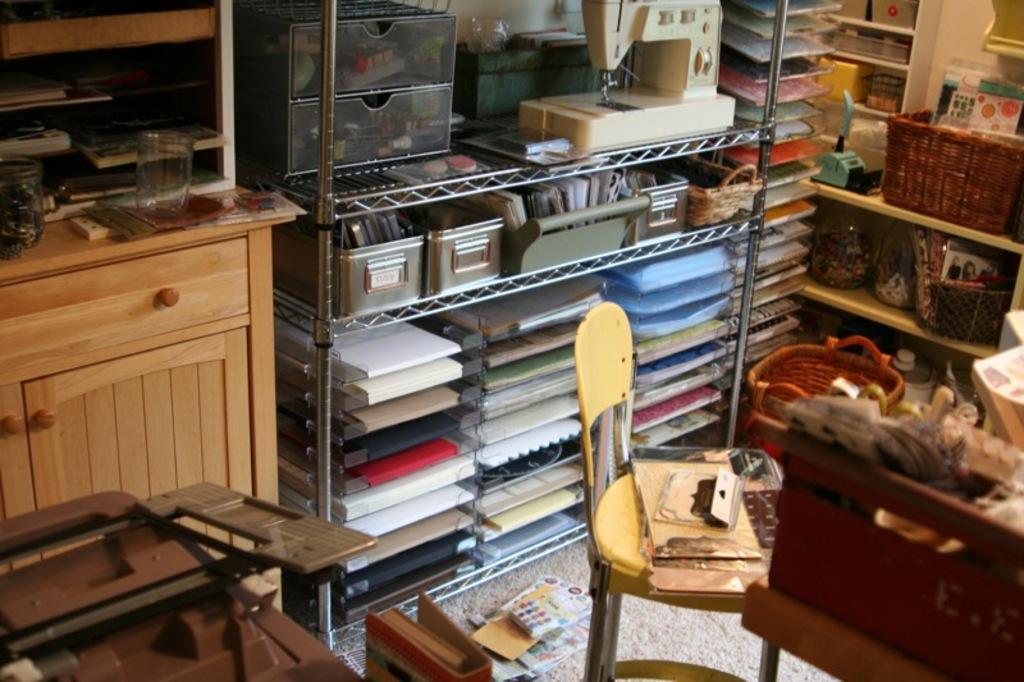In one or two sentences, can you explain what this image depicts? In this image there are shelves, there are objects on the shelves, there is a chair, there are objects on the chair, there is a table towards the bottom of the image, there are objects on the table, there is a machine towards the top of the image, there is an object towards the left of the image, there is a mat, there are objects on the mat, there is the wall. 